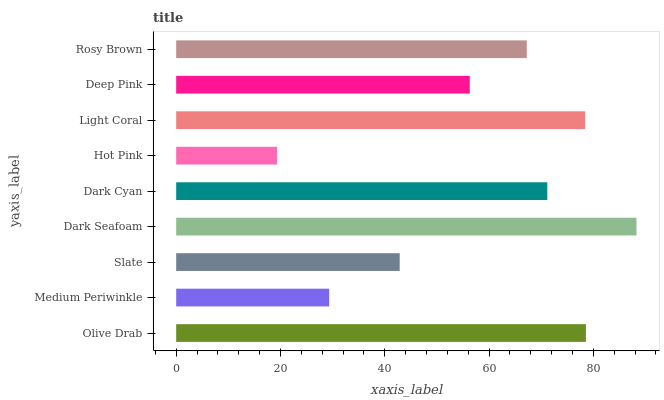Is Hot Pink the minimum?
Answer yes or no. Yes. Is Dark Seafoam the maximum?
Answer yes or no. Yes. Is Medium Periwinkle the minimum?
Answer yes or no. No. Is Medium Periwinkle the maximum?
Answer yes or no. No. Is Olive Drab greater than Medium Periwinkle?
Answer yes or no. Yes. Is Medium Periwinkle less than Olive Drab?
Answer yes or no. Yes. Is Medium Periwinkle greater than Olive Drab?
Answer yes or no. No. Is Olive Drab less than Medium Periwinkle?
Answer yes or no. No. Is Rosy Brown the high median?
Answer yes or no. Yes. Is Rosy Brown the low median?
Answer yes or no. Yes. Is Olive Drab the high median?
Answer yes or no. No. Is Deep Pink the low median?
Answer yes or no. No. 